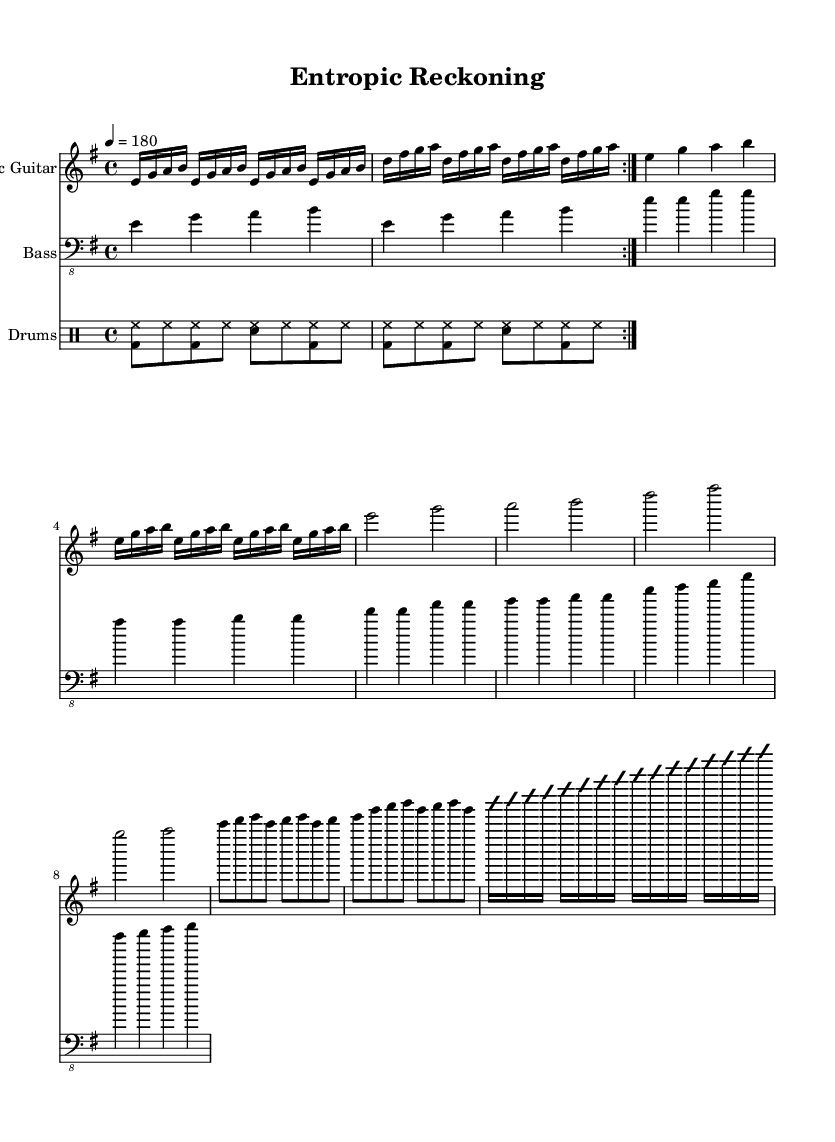What is the key signature of this music? The key signature is E minor, which has one sharp (F#) and is indicated at the beginning of the sheet music under the clef.
Answer: E minor What is the time signature of this music? The time signature is shown at the beginning of the sheet music as 4/4, indicating that there are four beats per measure and the quarter note gets one beat.
Answer: 4/4 What is the tempo marking for the piece? The tempo marking at the beginning indicates a speed of 180 beats per minute, guiding the performance pace for the musicians.
Answer: 180 How many measures are there in the verse section? The verse section contains 4 measures, identified by counting the measures between the successive double bar lines or repeating parts in the music.
Answer: 4 What is the instrument name for the main guitar part? The main guitar part is labeled as Electric Guitar at the beginning of its staff, helping musicians identify the specific instrumental voice for performance.
Answer: Electric Guitar Which section follows the solo in the music? After the solo, the music progresses back to the main vamp or repeated riff, often connecting back to the verse or chorus section based on typical song structure.
Answer: Main Riff Which drum pattern is utilized in the main section? The drum pattern in the main section consists of a kick drum on beats 1 and 3 and snare on beat 2 and 4, providing a driving rhythm typical in rock music.
Answer: <bd hh> 